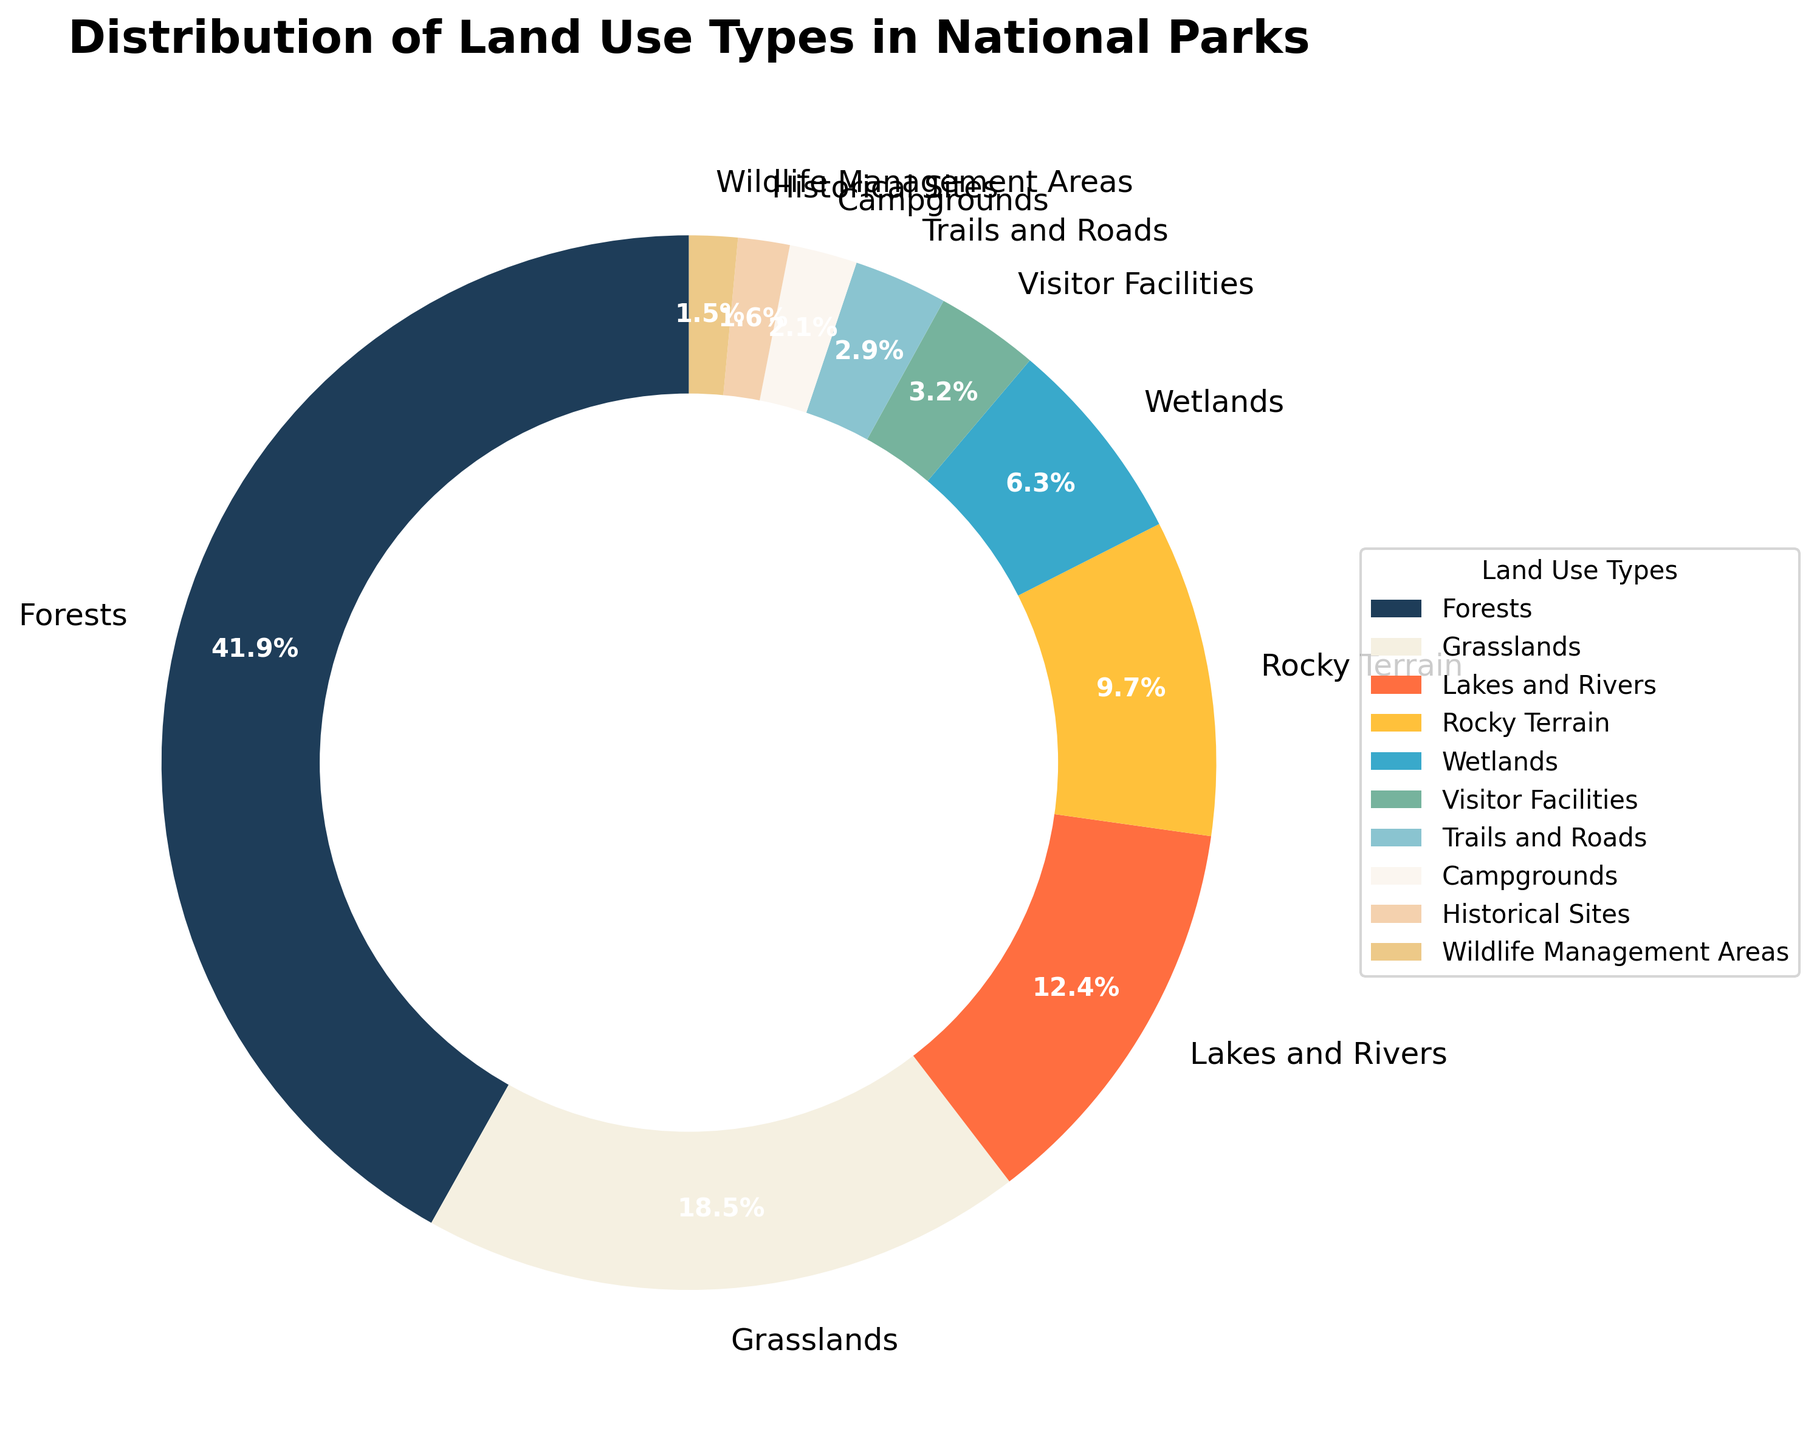Which land use type occupies the largest percentage of national parks? By looking at the largest section of the pie chart, we see that "Forests" occupy 42.3%.
Answer: Forests How much larger is the percentage of land covered by forests compared to grasslands? The percentage of land covered by forests is 42.3%, and the percentage for grasslands is 18.7%. The difference is 42.3% - 18.7% = 23.6%.
Answer: 23.6% Which land use types cover less than 5% of the national parks? By examining the smaller sections of the pie chart, the land use types that cover less than 5% are Visitor Facilities (3.2%), Trails and Roads (2.9%), Campgrounds (2.1%), Historical Sites (1.6%), and Wildlife Management Areas (1.5%).
Answer: Visitor Facilities, Trails and Roads, Campgrounds, Historical Sites, Wildlife Management Areas What is the combined percentage of lakes and rivers and wetlands in the national parks? By adding the percentages for lakes and rivers (12.5%) and wetlands (6.4%), we get 12.5% + 6.4% = 18.9%.
Answer: 18.9% Which section of the pie chart is represented by a dark blue color? Observing the color scheme of the pie chart, the section represented by a dark blue color corresponds to "Forests".
Answer: Forests Are the areas of lakes and rivers greater than, less than, or equal to the area of grasslands? Comparing the percentages, lakes and rivers cover 12.5% while grasslands cover 18.7%. Therefore, lakes and rivers cover less area than grasslands.
Answer: Less What is the total percentage of areas used for visitor-related activities (Visitor Facilities, Trails and Roads, Campgrounds)? Adding the percentages for Visitor Facilities (3.2%), Trails and Roads (2.9%), and Campgrounds (2.1%) gives us 3.2% + 2.9% + 2.1% = 8.2%.
Answer: 8.2% Which land use type is roughly equal in percentage to the sum of Historical Sites and Wildlife Management Areas? Summing the percentages of Historical Sites (1.6%) and Wildlife Management Areas (1.5%) gives us 1.6% + 1.5% = 3.1%, which is close to the percentage for Visitor Facilities (3.2%).
Answer: Visitor Facilities How many land use types occupy more than 10% of the national parks? By looking at the sections of the pie chart, only two land use types occupy more than 10%: Forests (42.3%) and Grasslands (18.7%).
Answer: 2 